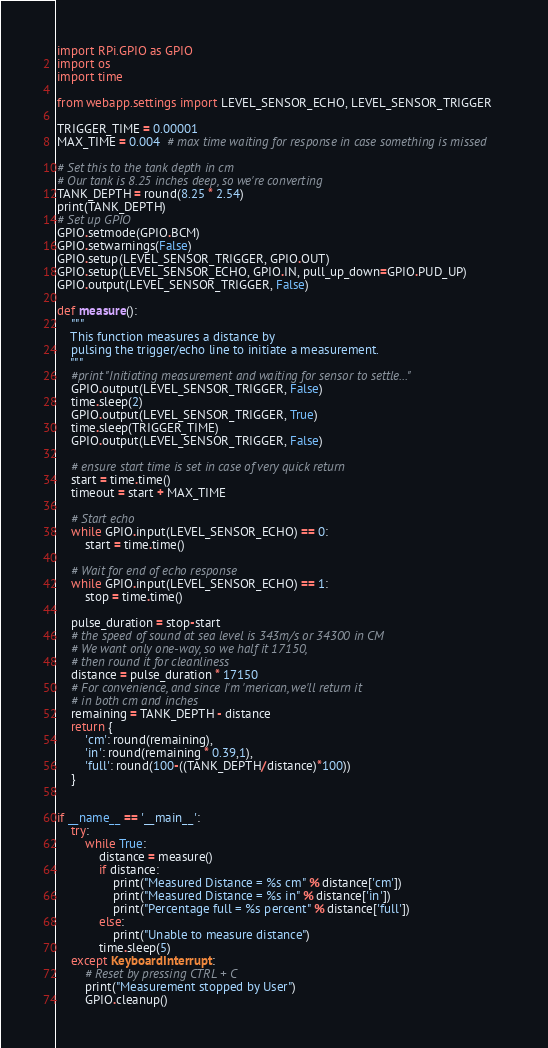Convert code to text. <code><loc_0><loc_0><loc_500><loc_500><_Python_>import RPi.GPIO as GPIO
import os
import time

from webapp.settings import LEVEL_SENSOR_ECHO, LEVEL_SENSOR_TRIGGER

TRIGGER_TIME = 0.00001
MAX_TIME = 0.004  # max time waiting for response in case something is missed

# Set this to the tank depth in cm
# Our tank is 8.25 inches deep, so we're converting
TANK_DEPTH = round(8.25 * 2.54)
print(TANK_DEPTH)
# Set up GPIO
GPIO.setmode(GPIO.BCM)
GPIO.setwarnings(False)
GPIO.setup(LEVEL_SENSOR_TRIGGER, GPIO.OUT)
GPIO.setup(LEVEL_SENSOR_ECHO, GPIO.IN, pull_up_down=GPIO.PUD_UP)
GPIO.output(LEVEL_SENSOR_TRIGGER, False)

def measure():
    """
    This function measures a distance by 
    pulsing the trigger/echo line to initiate a measurement.
    """
    #print "Initiating measurement and waiting for sensor to settle..."
    GPIO.output(LEVEL_SENSOR_TRIGGER, False)
    time.sleep(2)
    GPIO.output(LEVEL_SENSOR_TRIGGER, True)
    time.sleep(TRIGGER_TIME)
    GPIO.output(LEVEL_SENSOR_TRIGGER, False)

    # ensure start time is set in case of very quick return
    start = time.time()
    timeout = start + MAX_TIME

    # Start echo
    while GPIO.input(LEVEL_SENSOR_ECHO) == 0:
        start = time.time()

    # Wait for end of echo response
    while GPIO.input(LEVEL_SENSOR_ECHO) == 1:
        stop = time.time()

    pulse_duration = stop-start
    # the speed of sound at sea level is 343m/s or 34300 in CM
    # We want only one-way, so we half it 17150,
    # then round it for cleanliness
    distance = pulse_duration * 17150
    # For convenience, and since I'm 'merican, we'll return it
    # in both cm and inches
    remaining = TANK_DEPTH - distance
    return {
        'cm': round(remaining),
        'in': round(remaining * 0.39,1),
        'full': round(100-((TANK_DEPTH/distance)*100))
    }


if __name__ == '__main__':
    try:
        while True:
            distance = measure()
            if distance:
                print("Measured Distance = %s cm" % distance['cm'])
                print("Measured Distance = %s in" % distance['in'])
                print("Percentage full = %s percent" % distance['full'])
            else:
                print("Unable to measure distance")
            time.sleep(5)
    except KeyboardInterrupt:
        # Reset by pressing CTRL + C
        print("Measurement stopped by User")
        GPIO.cleanup()
</code> 